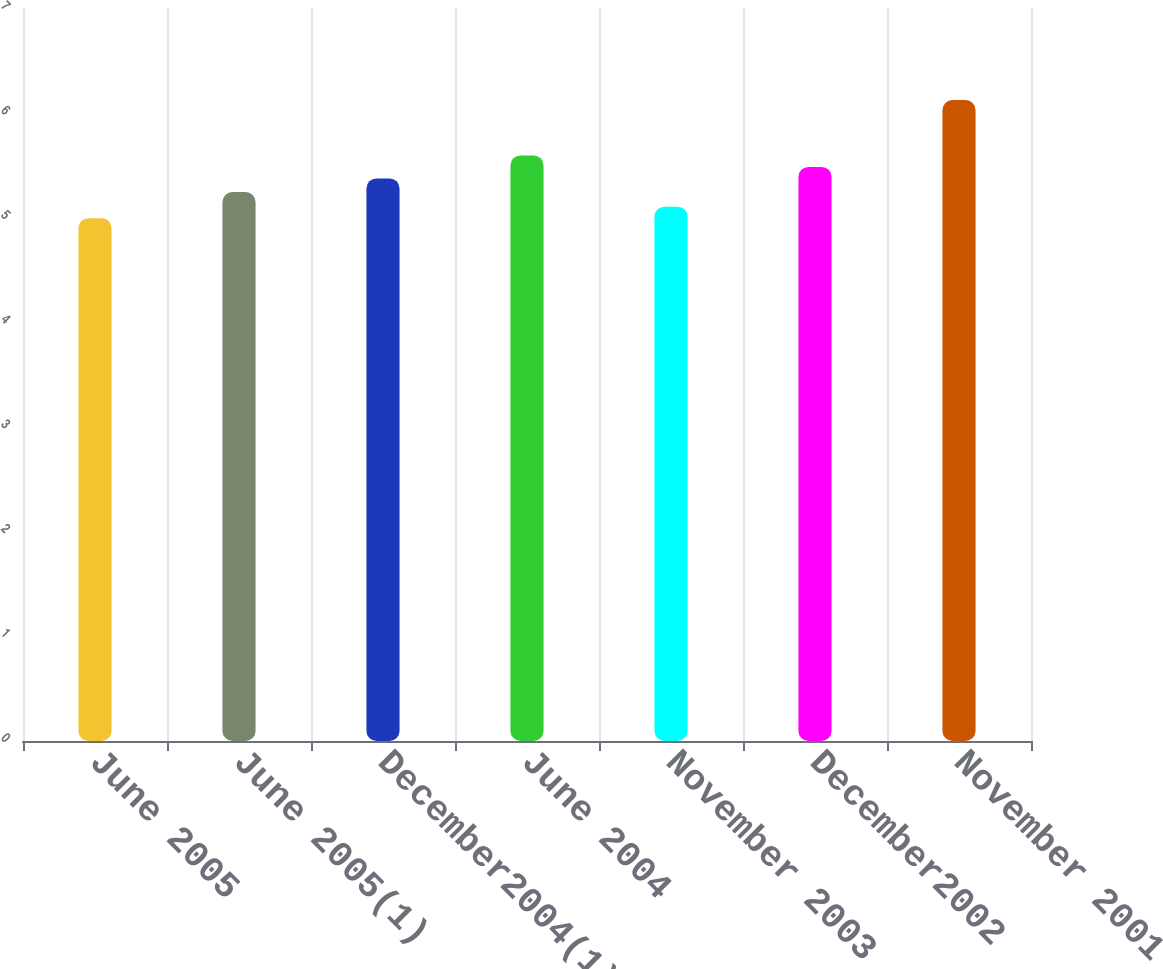Convert chart. <chart><loc_0><loc_0><loc_500><loc_500><bar_chart><fcel>June 2005<fcel>June 2005(1)<fcel>December2004(1)<fcel>June 2004<fcel>November 2003<fcel>December2002<fcel>November 2001<nl><fcel>5<fcel>5.25<fcel>5.38<fcel>5.6<fcel>5.11<fcel>5.49<fcel>6.13<nl></chart> 